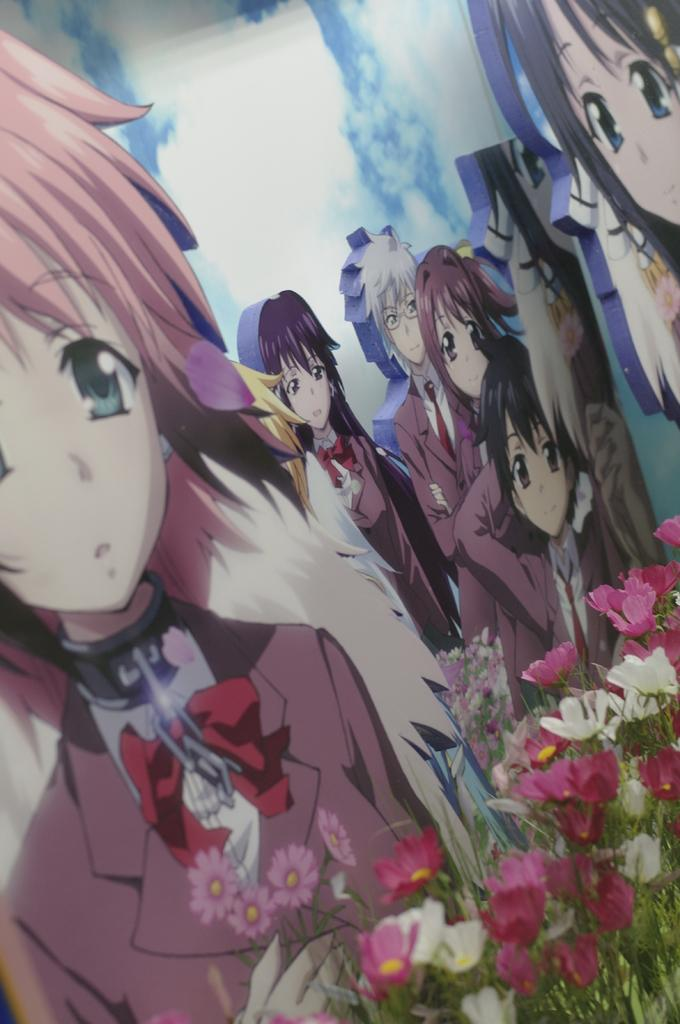What is the main subject of the image? There is a painting in the image. What is depicted in the painting? The painting depicts people. What other elements can be seen in the image besides the painting? There are flowers and plants in the image. What type of lunch is being served to the committee in the image? There is no lunch or committee present in the image; it only features a painting with people, flowers, and plants. 